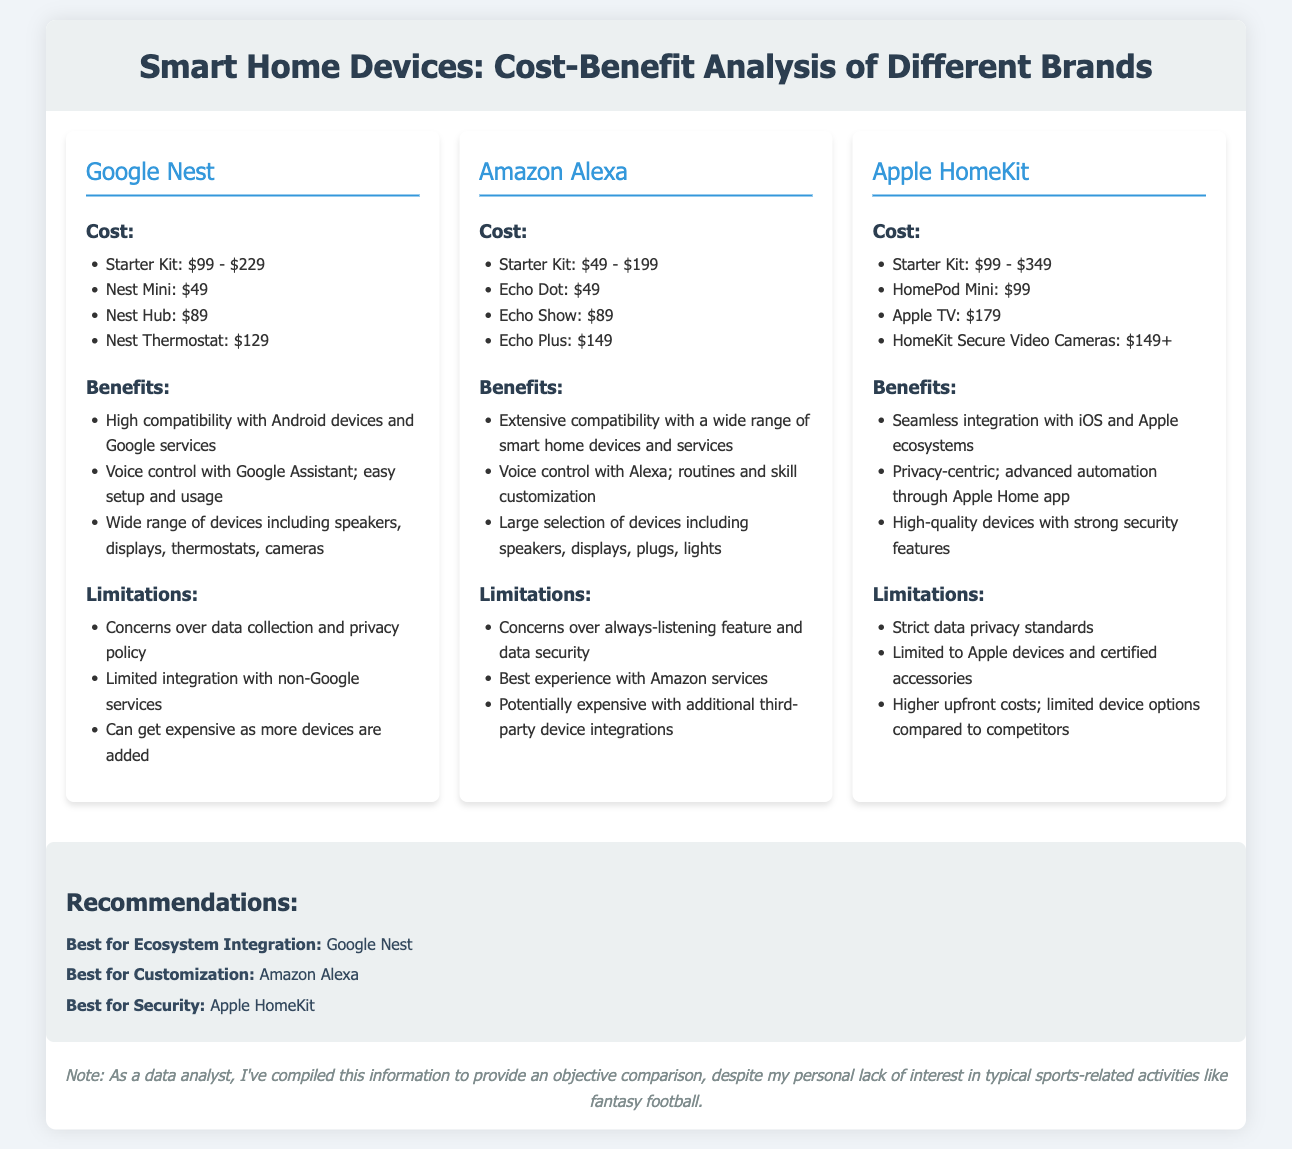what is the cost range for the Google Nest starter kit? The cost range for the Google Nest starter kit is specified as $99 to $229.
Answer: $99 - $229 which smart home device has the highest starting price? The Apple HomeKit has the highest starting price for its starter kit, which ranges from $99 to $349.
Answer: $99 - $349 what is a major benefit of Amazon Alexa? A major benefit of Amazon Alexa is its extensive compatibility with a wide range of smart home devices and services.
Answer: Extensive compatibility what limitation does Apple HomeKit have? Apple HomeKit has a limitation of being limited to Apple devices and certified accessories.
Answer: Limited to Apple devices which brand is recommended for customization? The brand recommended for customization is Amazon Alexa.
Answer: Amazon Alexa how much does the Nest Mini cost? The Nest Mini costs $49.
Answer: $49 what is a common concern among all three brands? A common concern among all three brands is data privacy or security issues related to their devices.
Answer: Data privacy concerns which brand offers voice control with its own assistant? Google Nest offers voice control with Google Assistant.
Answer: Google Assistant how many devices are included in the comparison? The comparison includes three devices: Google Nest, Amazon Alexa, and Apple HomeKit.
Answer: Three devices 